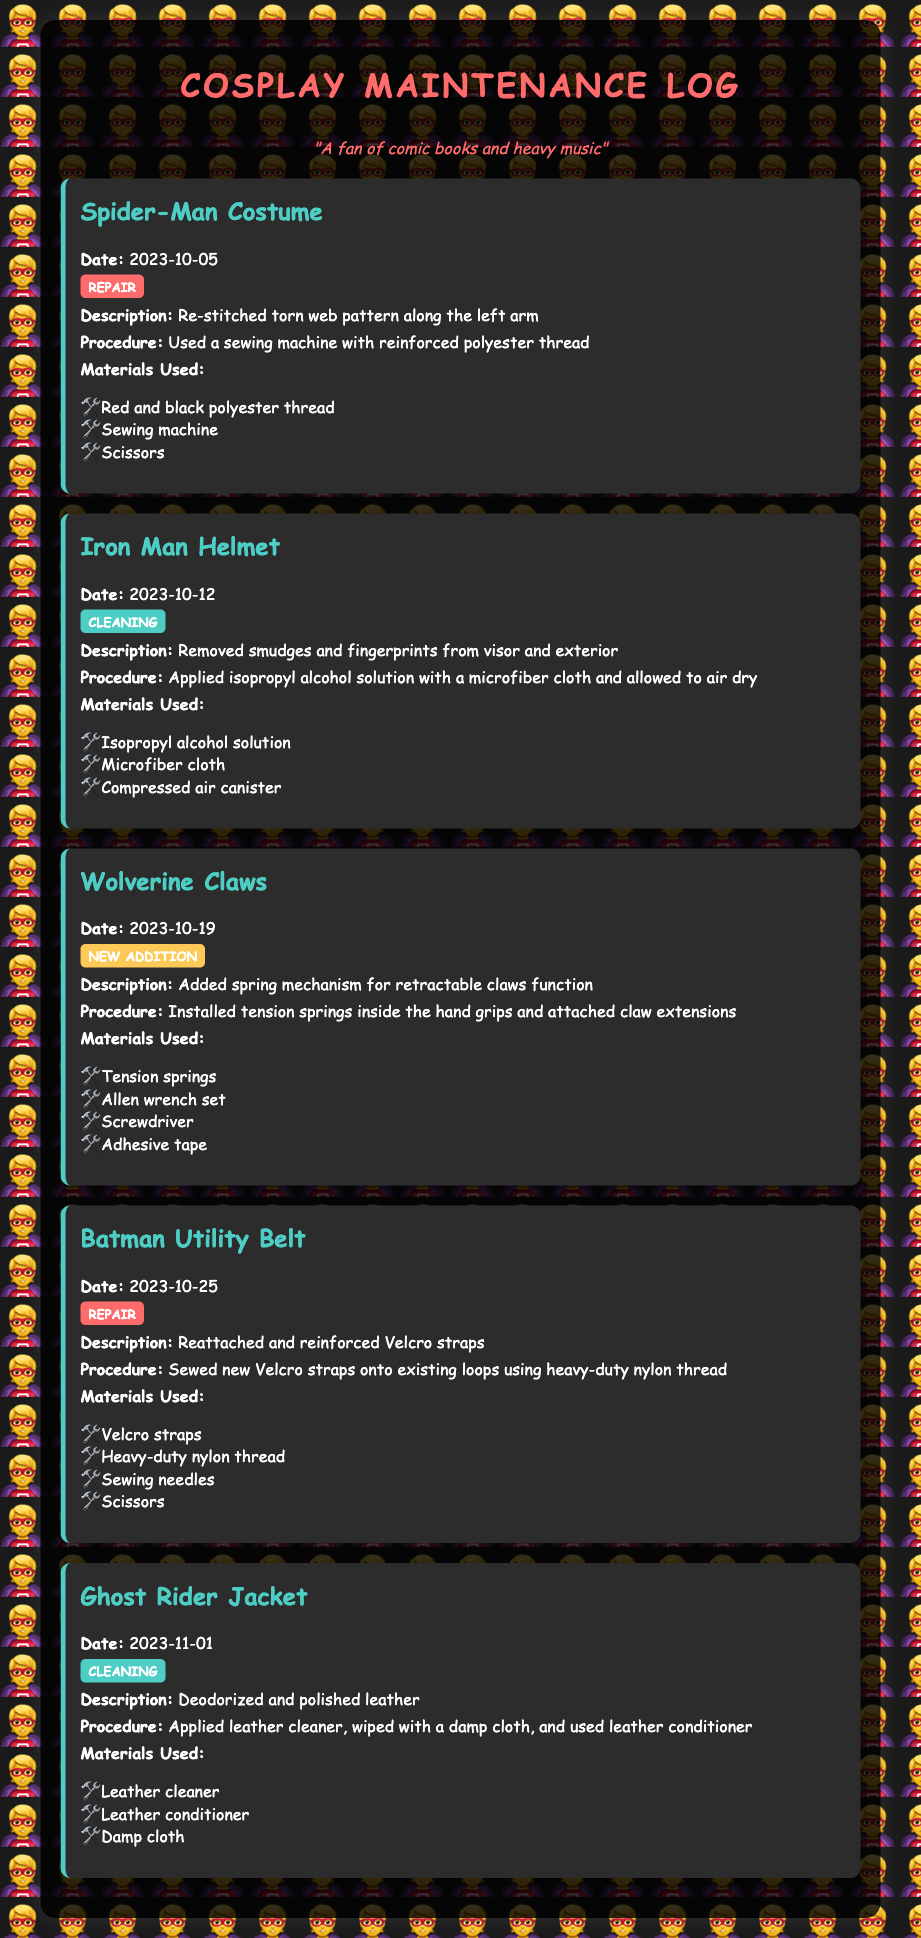what is the date of the Spider-Man costume repair? The date recorded for the Spider-Man costume repair is found under its entry, listed as 2023-10-05.
Answer: 2023-10-05 what procedure was used for cleaning the Iron Man helmet? The procedure for cleaning the Iron Man helmet involves applying isopropyl alcohol solution with a microfiber cloth and allowing it to air dry.
Answer: Applied isopropyl alcohol solution with a microfiber cloth and allowed to air dry how many entries are documented in total? The total number of entries can be counted from the individual costume entries listed, which amounts to five.
Answer: 5 which costume had a new addition implemented? The costume that had a new addition implemented is specified under the Wolverine Claws entry.
Answer: Wolverine Claws what type of maintenance was performed on the Ghost Rider jacket? The type of maintenance performed on the Ghost Rider jacket is noted in its entry as cleaning.
Answer: Cleaning 